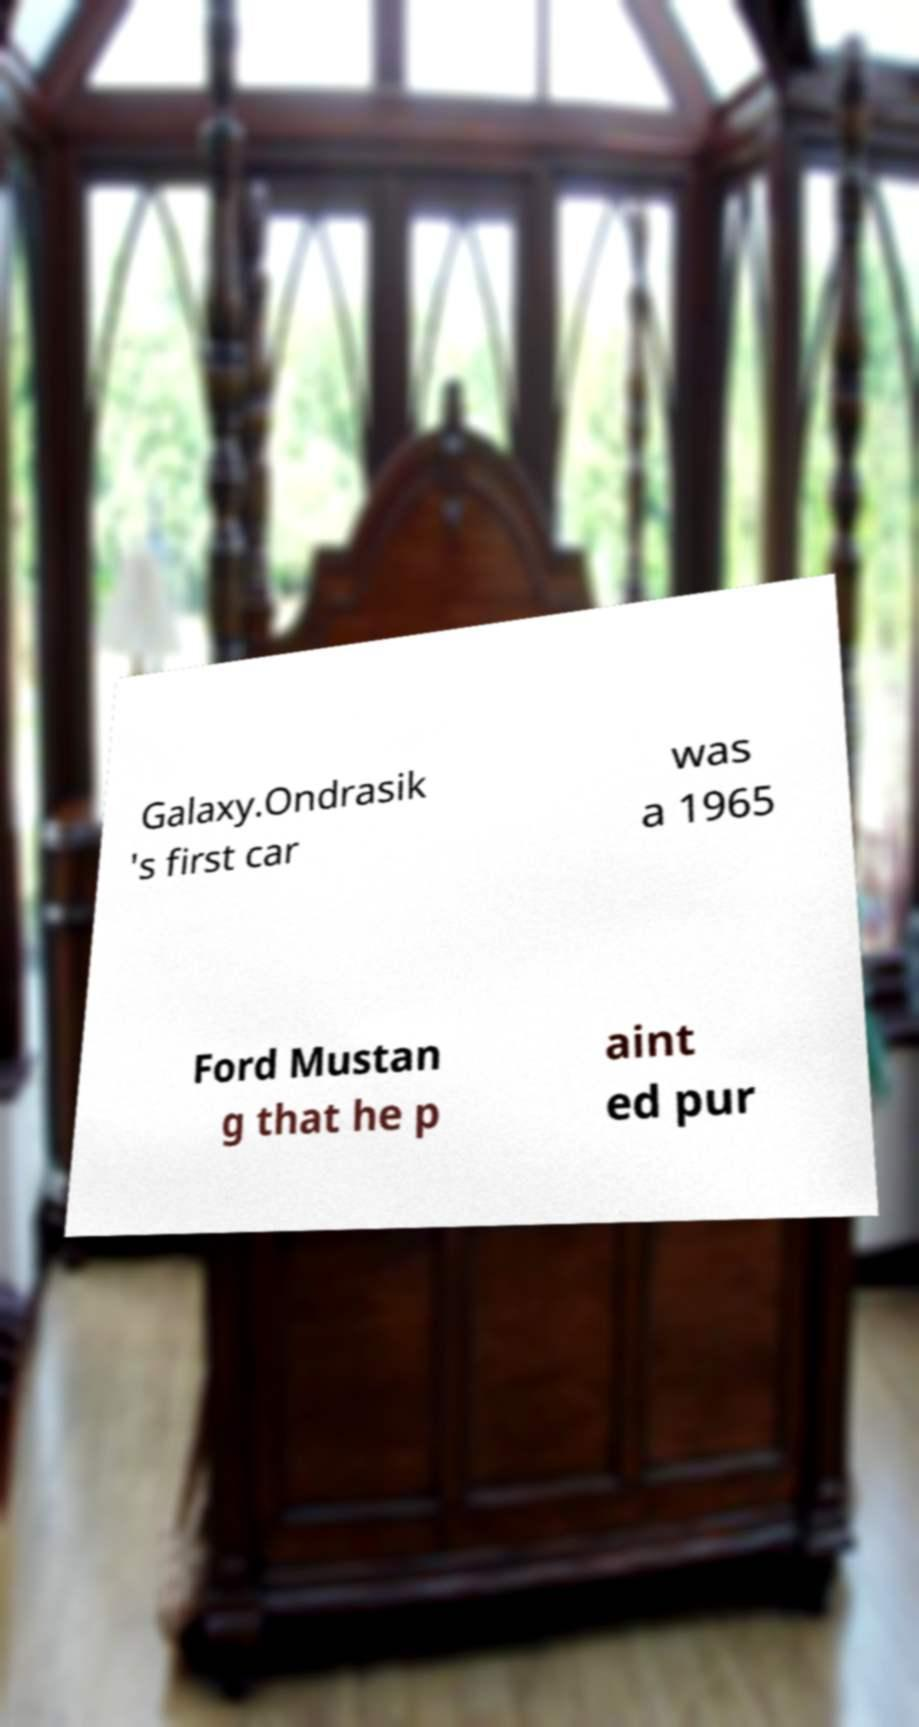I need the written content from this picture converted into text. Can you do that? Galaxy.Ondrasik 's first car was a 1965 Ford Mustan g that he p aint ed pur 